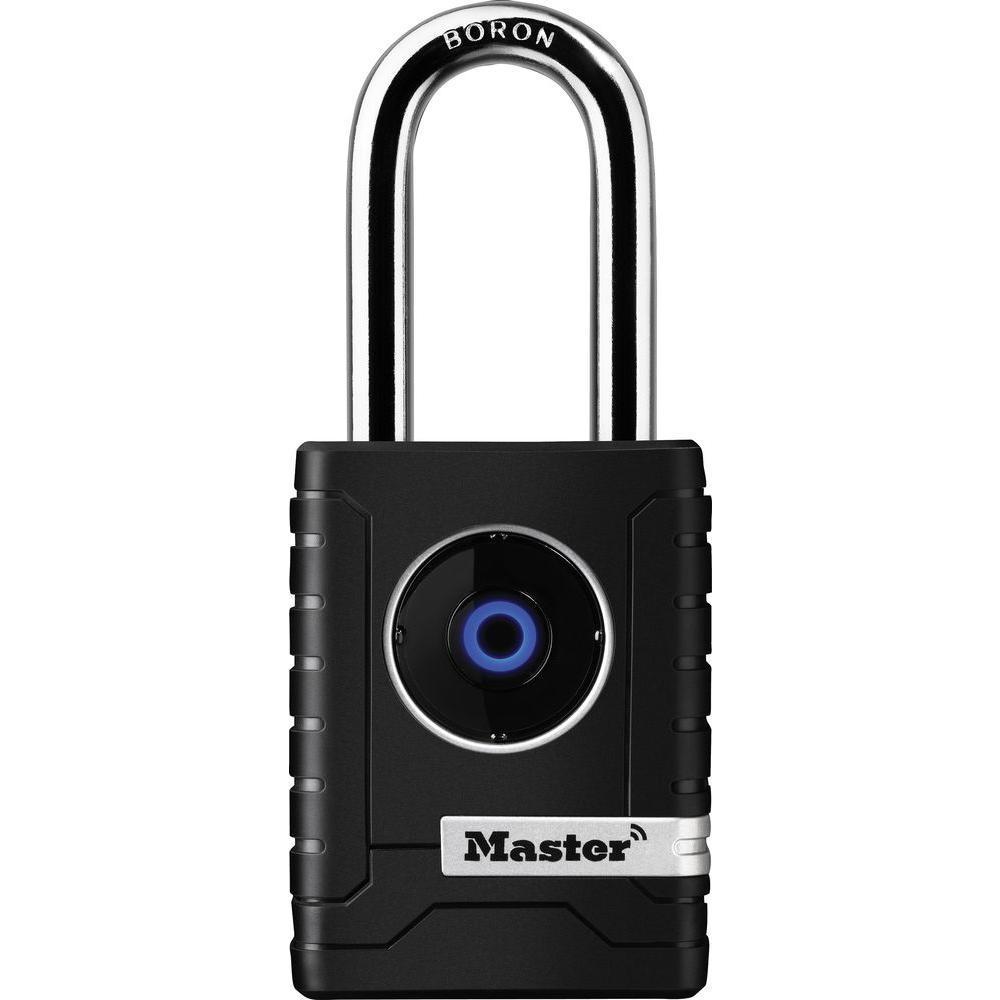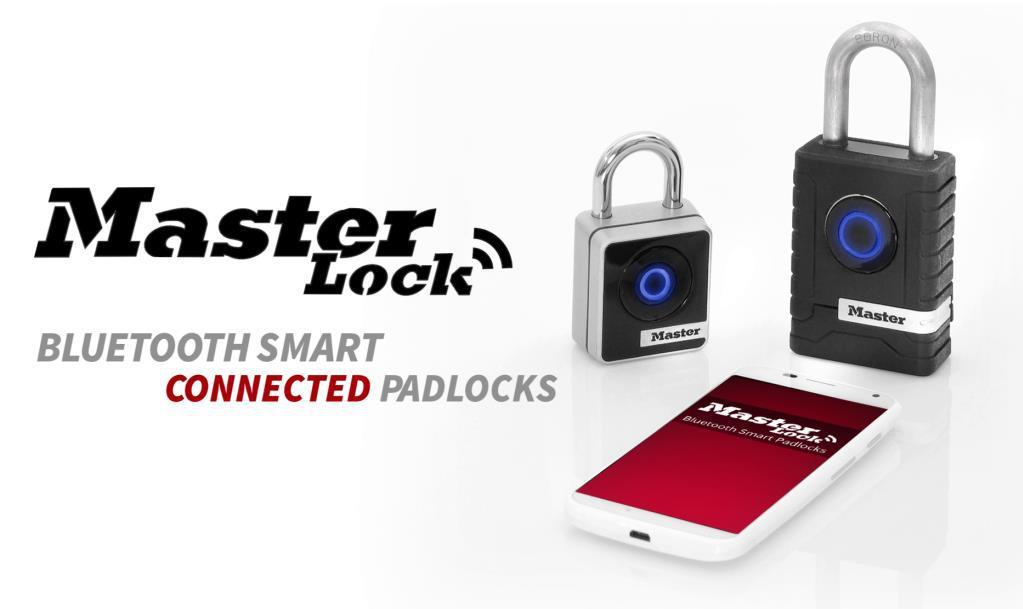The first image is the image on the left, the second image is the image on the right. Examine the images to the left and right. Is the description "At least one image is a manual mechanical combination lock with a logo design other than a blue circle." accurate? Answer yes or no. No. The first image is the image on the left, the second image is the image on the right. Assess this claim about the two images: "An image shows a lock with three rows of numbers to enter the combination.". Correct or not? Answer yes or no. No. The first image is the image on the left, the second image is the image on the right. Examine the images to the left and right. Is the description "There is a numbered padlock in one of the images." accurate? Answer yes or no. No. The first image is the image on the left, the second image is the image on the right. Given the left and right images, does the statement "One lock features a red diamond shape on the front of a lock near three vertical combination wheels." hold true? Answer yes or no. No. 